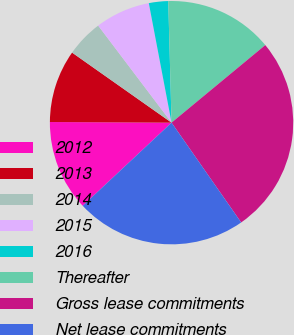Convert chart to OTSL. <chart><loc_0><loc_0><loc_500><loc_500><pie_chart><fcel>2012<fcel>2013<fcel>2014<fcel>2015<fcel>2016<fcel>Thereafter<fcel>Gross lease commitments<fcel>Net lease commitments<nl><fcel>12.06%<fcel>9.68%<fcel>4.93%<fcel>7.31%<fcel>2.56%<fcel>14.43%<fcel>26.31%<fcel>22.72%<nl></chart> 